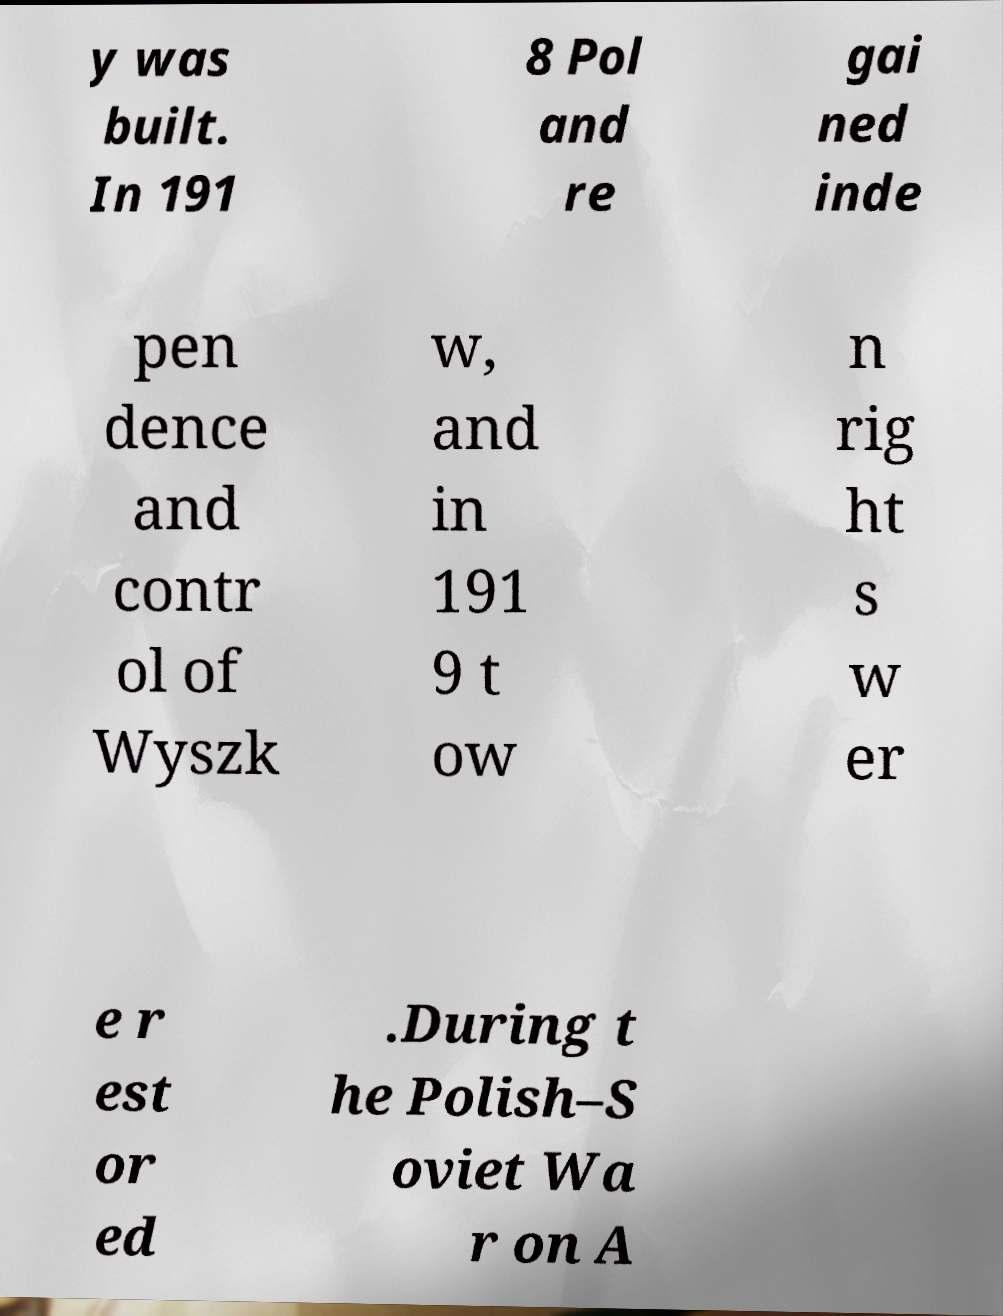Please read and relay the text visible in this image. What does it say? y was built. In 191 8 Pol and re gai ned inde pen dence and contr ol of Wyszk w, and in 191 9 t ow n rig ht s w er e r est or ed .During t he Polish–S oviet Wa r on A 